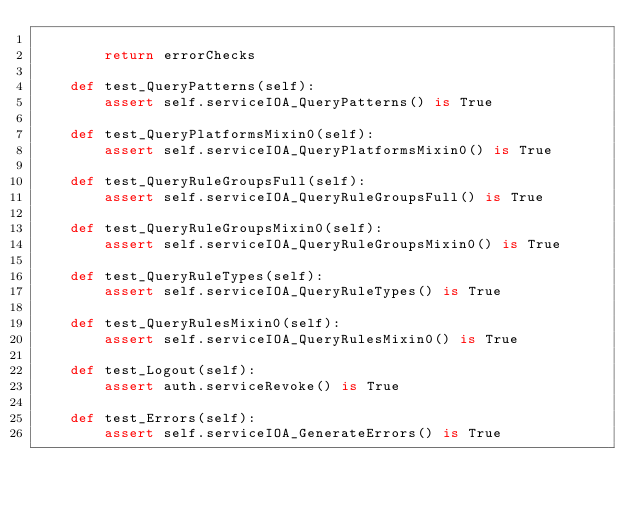<code> <loc_0><loc_0><loc_500><loc_500><_Python_>
        return errorChecks

    def test_QueryPatterns(self):
        assert self.serviceIOA_QueryPatterns() is True

    def test_QueryPlatformsMixin0(self):
        assert self.serviceIOA_QueryPlatformsMixin0() is True

    def test_QueryRuleGroupsFull(self):
        assert self.serviceIOA_QueryRuleGroupsFull() is True

    def test_QueryRuleGroupsMixin0(self):
        assert self.serviceIOA_QueryRuleGroupsMixin0() is True

    def test_QueryRuleTypes(self):
        assert self.serviceIOA_QueryRuleTypes() is True

    def test_QueryRulesMixin0(self):
        assert self.serviceIOA_QueryRulesMixin0() is True

    def test_Logout(self):
        assert auth.serviceRevoke() is True

    def test_Errors(self):
        assert self.serviceIOA_GenerateErrors() is True
</code> 